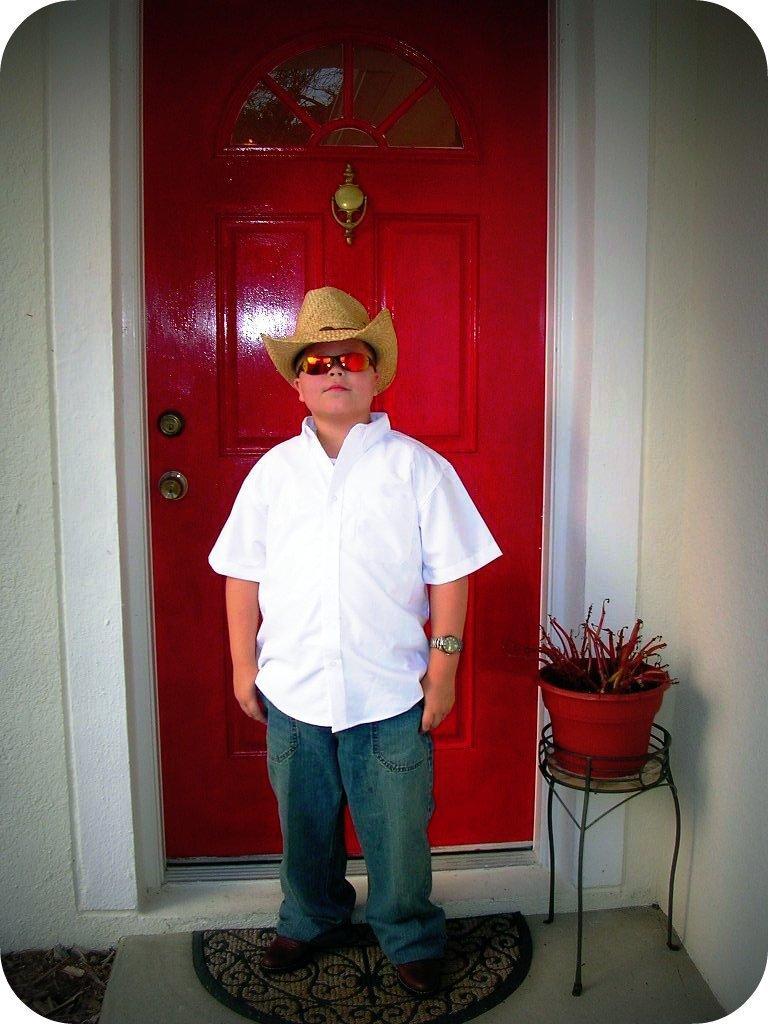In one or two sentences, can you explain what this image depicts? There is a boy standing and wore glasses and hat. Background we can see wall and red color door. 